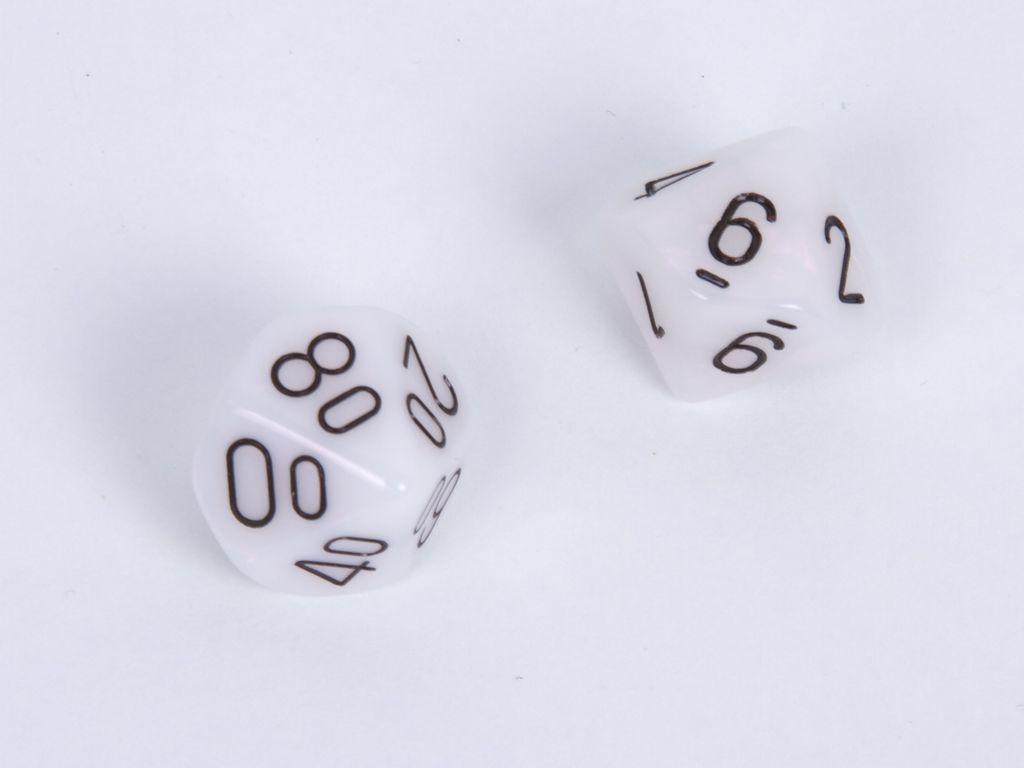Please provide a concise description of this image. In this image there are two dice. 